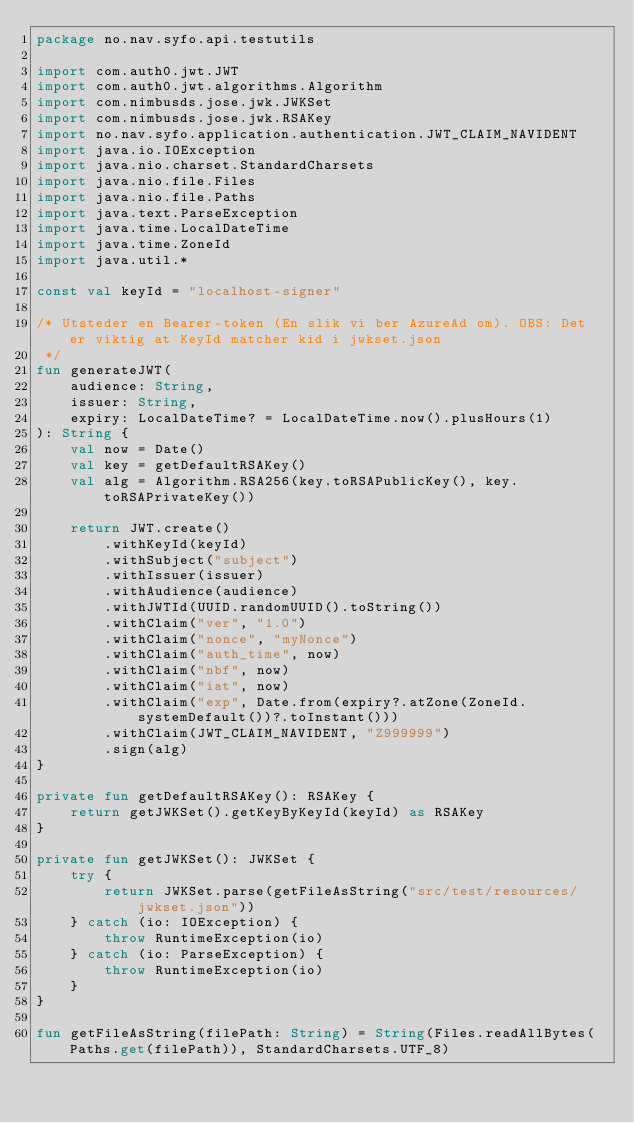Convert code to text. <code><loc_0><loc_0><loc_500><loc_500><_Kotlin_>package no.nav.syfo.api.testutils

import com.auth0.jwt.JWT
import com.auth0.jwt.algorithms.Algorithm
import com.nimbusds.jose.jwk.JWKSet
import com.nimbusds.jose.jwk.RSAKey
import no.nav.syfo.application.authentication.JWT_CLAIM_NAVIDENT
import java.io.IOException
import java.nio.charset.StandardCharsets
import java.nio.file.Files
import java.nio.file.Paths
import java.text.ParseException
import java.time.LocalDateTime
import java.time.ZoneId
import java.util.*

const val keyId = "localhost-signer"

/* Utsteder en Bearer-token (En slik vi ber AzureAd om). OBS: Det er viktig at KeyId matcher kid i jwkset.json
 */
fun generateJWT(
    audience: String,
    issuer: String,
    expiry: LocalDateTime? = LocalDateTime.now().plusHours(1)
): String {
    val now = Date()
    val key = getDefaultRSAKey()
    val alg = Algorithm.RSA256(key.toRSAPublicKey(), key.toRSAPrivateKey())

    return JWT.create()
        .withKeyId(keyId)
        .withSubject("subject")
        .withIssuer(issuer)
        .withAudience(audience)
        .withJWTId(UUID.randomUUID().toString())
        .withClaim("ver", "1.0")
        .withClaim("nonce", "myNonce")
        .withClaim("auth_time", now)
        .withClaim("nbf", now)
        .withClaim("iat", now)
        .withClaim("exp", Date.from(expiry?.atZone(ZoneId.systemDefault())?.toInstant()))
        .withClaim(JWT_CLAIM_NAVIDENT, "Z999999")
        .sign(alg)
}

private fun getDefaultRSAKey(): RSAKey {
    return getJWKSet().getKeyByKeyId(keyId) as RSAKey
}

private fun getJWKSet(): JWKSet {
    try {
        return JWKSet.parse(getFileAsString("src/test/resources/jwkset.json"))
    } catch (io: IOException) {
        throw RuntimeException(io)
    } catch (io: ParseException) {
        throw RuntimeException(io)
    }
}

fun getFileAsString(filePath: String) = String(Files.readAllBytes(Paths.get(filePath)), StandardCharsets.UTF_8)
</code> 